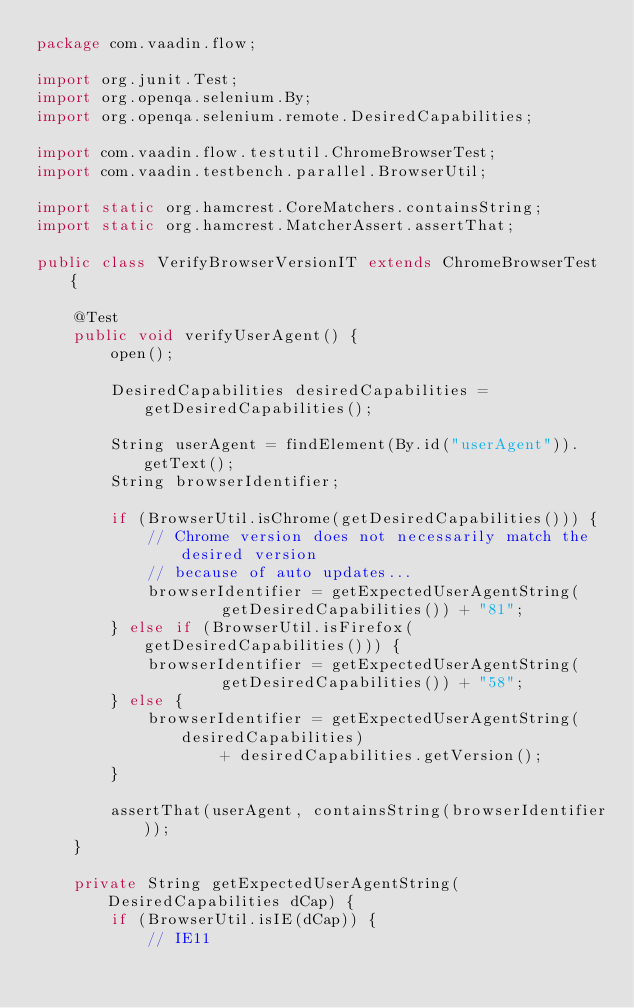Convert code to text. <code><loc_0><loc_0><loc_500><loc_500><_Java_>package com.vaadin.flow;

import org.junit.Test;
import org.openqa.selenium.By;
import org.openqa.selenium.remote.DesiredCapabilities;

import com.vaadin.flow.testutil.ChromeBrowserTest;
import com.vaadin.testbench.parallel.BrowserUtil;

import static org.hamcrest.CoreMatchers.containsString;
import static org.hamcrest.MatcherAssert.assertThat;

public class VerifyBrowserVersionIT extends ChromeBrowserTest {

    @Test
    public void verifyUserAgent() {
        open();

        DesiredCapabilities desiredCapabilities = getDesiredCapabilities();

        String userAgent = findElement(By.id("userAgent")).getText();
        String browserIdentifier;

        if (BrowserUtil.isChrome(getDesiredCapabilities())) {
            // Chrome version does not necessarily match the desired version
            // because of auto updates...
            browserIdentifier = getExpectedUserAgentString(
                    getDesiredCapabilities()) + "81";
        } else if (BrowserUtil.isFirefox(getDesiredCapabilities())) {
            browserIdentifier = getExpectedUserAgentString(
                    getDesiredCapabilities()) + "58";
        } else {
            browserIdentifier = getExpectedUserAgentString(desiredCapabilities)
                    + desiredCapabilities.getVersion();
        }

        assertThat(userAgent, containsString(browserIdentifier));
    }

    private String getExpectedUserAgentString(DesiredCapabilities dCap) {
        if (BrowserUtil.isIE(dCap)) {
            // IE11</code> 